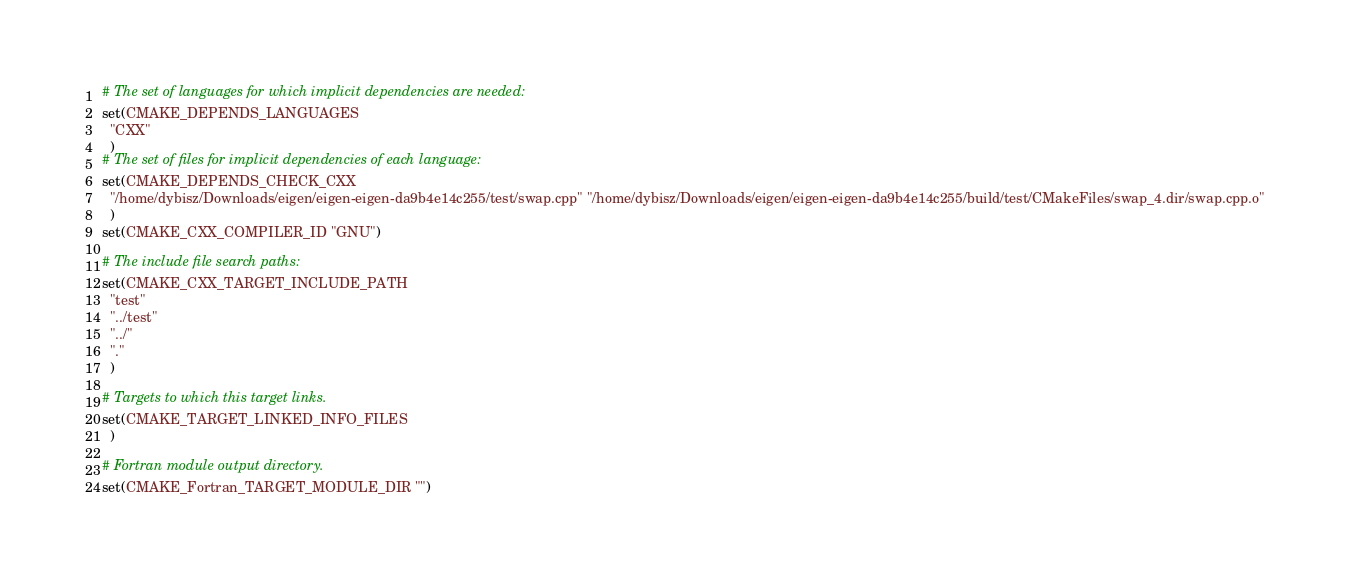<code> <loc_0><loc_0><loc_500><loc_500><_CMake_># The set of languages for which implicit dependencies are needed:
set(CMAKE_DEPENDS_LANGUAGES
  "CXX"
  )
# The set of files for implicit dependencies of each language:
set(CMAKE_DEPENDS_CHECK_CXX
  "/home/dybisz/Downloads/eigen/eigen-eigen-da9b4e14c255/test/swap.cpp" "/home/dybisz/Downloads/eigen/eigen-eigen-da9b4e14c255/build/test/CMakeFiles/swap_4.dir/swap.cpp.o"
  )
set(CMAKE_CXX_COMPILER_ID "GNU")

# The include file search paths:
set(CMAKE_CXX_TARGET_INCLUDE_PATH
  "test"
  "../test"
  "../"
  "."
  )

# Targets to which this target links.
set(CMAKE_TARGET_LINKED_INFO_FILES
  )

# Fortran module output directory.
set(CMAKE_Fortran_TARGET_MODULE_DIR "")
</code> 